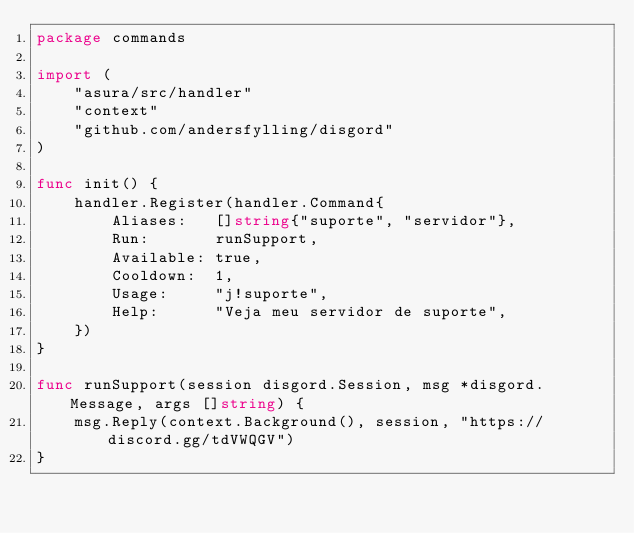Convert code to text. <code><loc_0><loc_0><loc_500><loc_500><_Go_>package commands

import (
	"asura/src/handler"
	"context"
	"github.com/andersfylling/disgord"
)

func init() {
	handler.Register(handler.Command{
		Aliases:   []string{"suporte", "servidor"},
		Run:       runSupport,
		Available: true,
		Cooldown:  1,
		Usage:     "j!suporte",
		Help:      "Veja meu servidor de suporte",
	})
}

func runSupport(session disgord.Session, msg *disgord.Message, args []string) {
	msg.Reply(context.Background(), session, "https://discord.gg/tdVWQGV")
}
</code> 